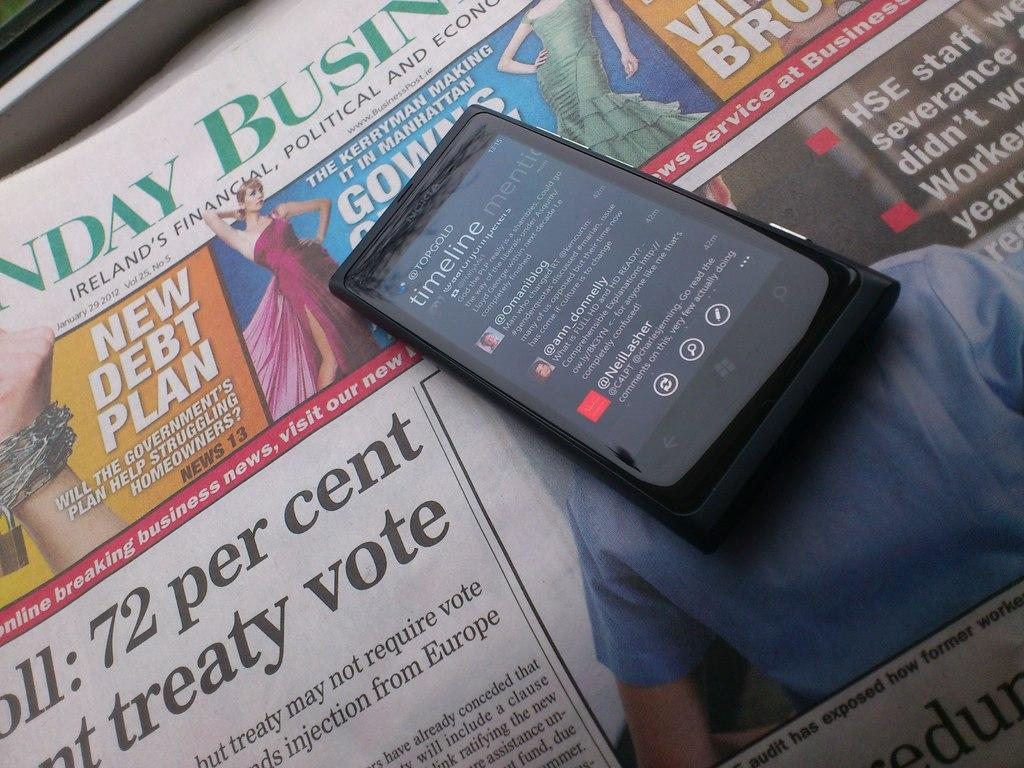What electronic device is present in the image? There is a mobile phone in the image. What is the mobile phone placed on? The mobile phone is on a newspaper. What type of cable is connected to the mobile phone in the image? There is no cable connected to the mobile phone in the image. 